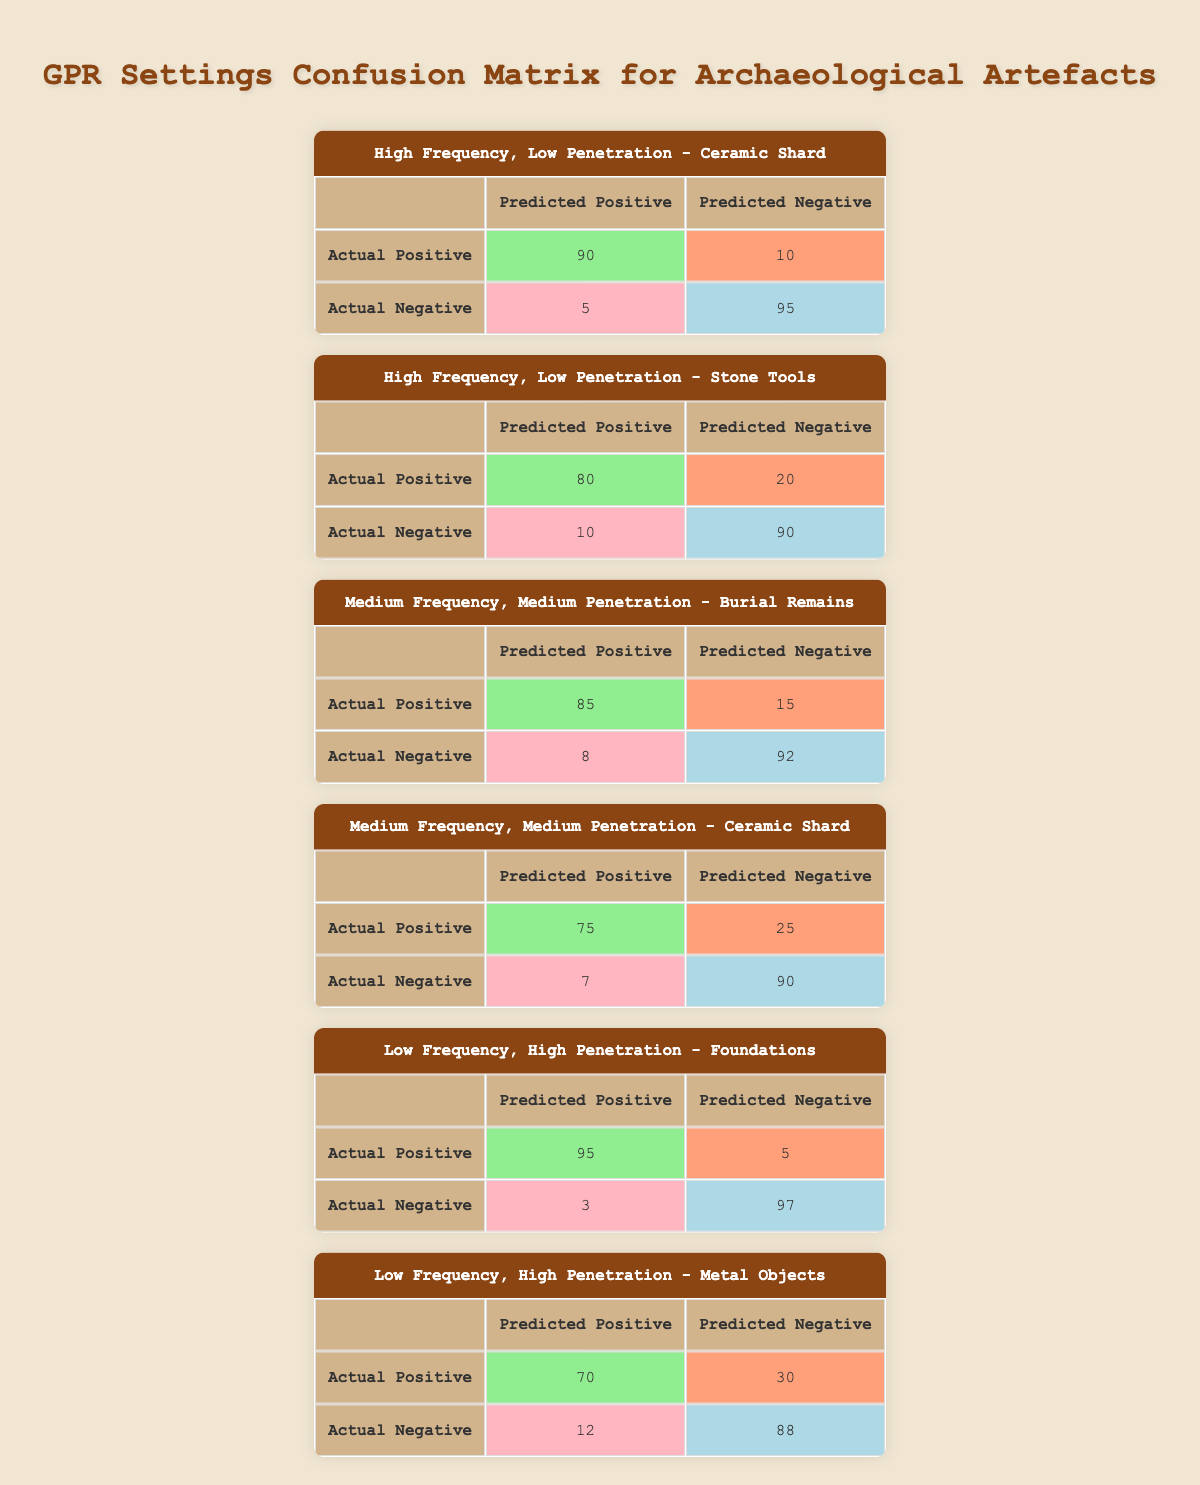What is the true positive count for Ceramic Shard using High Frequency, Low Penetration setting? The table shows that the true positive count for Ceramic Shard under the High Frequency, Low Penetration setting is 90, as found in the corresponding matrix.
Answer: 90 What are the false negatives for Metal Objects using Low Frequency, High Penetration? The matrix for Low Frequency, High Penetration indicates a false negative count of 30 for Metal Objects, which is directly extracted from the table.
Answer: 30 Is the true negative count for Burial Remains higher than that for Ceramic Shard using Medium Frequency, Medium Penetration? The true negative for Burial Remains is 92 while that for Ceramic Shard is 90. Since 92 is greater than 90, the statement is true.
Answer: Yes What is the total true positive count for both types of artefacts detected with Low Frequency, High Penetration? The true positives for Foundations and Metal Objects are 95 and 70 respectively. Summing these values gives 95 + 70 = 165.
Answer: 165 Which GPR setting has the highest true negative count? Assessing the true negatives across all settings, Foundations (97) has the highest true negative count compared to others. This is identified from the matrix of each setting.
Answer: Low Frequency, High Penetration What is the average false positive rate for all GPR settings? The false positive counts are 5, 10, 8, 7, 3, and 12 respectively. Summing these gives 45, and there are 6 settings, thus the average is 45/6 = 7.5.
Answer: 7.5 Are there more true positives for Ceramic Shard in High Frequency, Low Penetration than for Stone Tools in the same setting? The true positives for Ceramic Shard (90) is greater than for Stone Tools (80) when comparing respective counts from the table.
Answer: Yes How many artefacts have a false positive count greater than 10? Checking the matrices, only Metal Objects (12) has a false positive count greater than 10, while others have counts less than or equal to 10. Therefore, there is only 1 artefact.
Answer: 1 